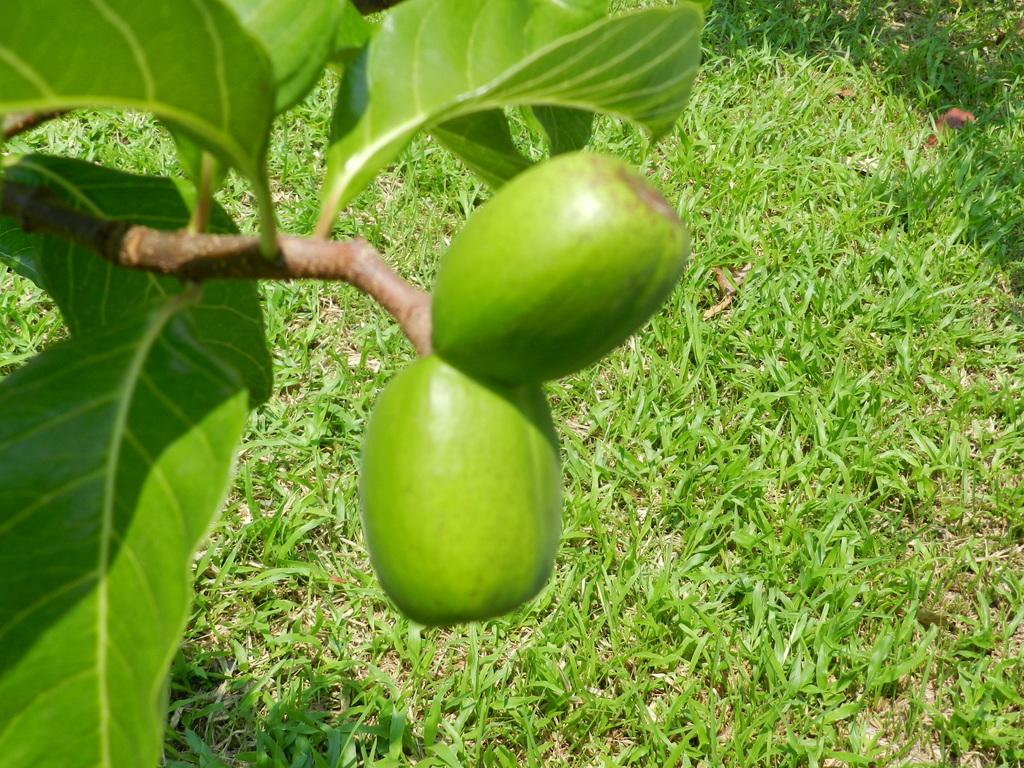What is hanging from the branch in the image? There are two fruits hanging from a branch in the image. What type of plant is depicted in the image? The image contains a tree with branches and leaves. What type of vegetation is visible at the base of the tree? There is grass visible in the image. What type of underwear can be seen hanging from the tree in the image? There is no underwear present in the image; it features two fruits hanging from a branch. How does the tree's acoustics affect the sound quality in the image? There is no information about the tree's acoustics or any sound quality in the image. 